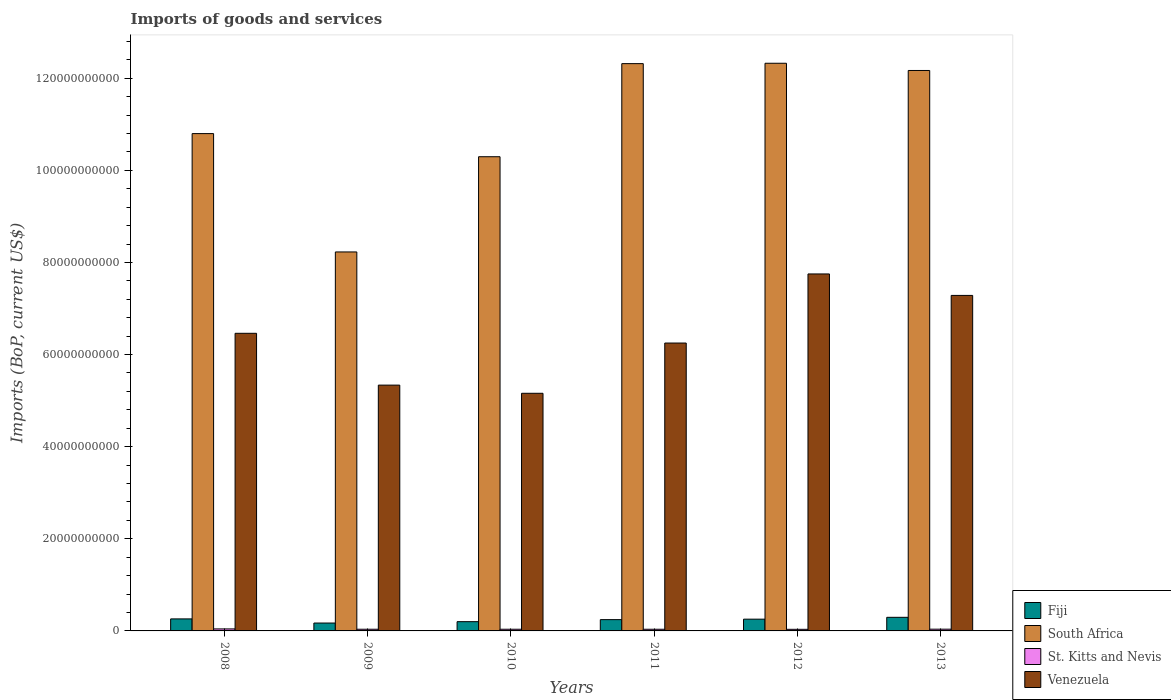How many different coloured bars are there?
Your answer should be very brief. 4. How many groups of bars are there?
Make the answer very short. 6. What is the label of the 1st group of bars from the left?
Provide a succinct answer. 2008. What is the amount spent on imports in South Africa in 2013?
Offer a terse response. 1.22e+11. Across all years, what is the maximum amount spent on imports in South Africa?
Ensure brevity in your answer.  1.23e+11. Across all years, what is the minimum amount spent on imports in Venezuela?
Your answer should be very brief. 5.16e+1. What is the total amount spent on imports in Fiji in the graph?
Provide a succinct answer. 1.43e+1. What is the difference between the amount spent on imports in Fiji in 2008 and that in 2011?
Your answer should be very brief. 1.58e+08. What is the difference between the amount spent on imports in St. Kitts and Nevis in 2011 and the amount spent on imports in Venezuela in 2010?
Keep it short and to the point. -5.12e+1. What is the average amount spent on imports in Fiji per year?
Your answer should be very brief. 2.38e+09. In the year 2010, what is the difference between the amount spent on imports in South Africa and amount spent on imports in Venezuela?
Your answer should be very brief. 5.14e+1. What is the ratio of the amount spent on imports in St. Kitts and Nevis in 2010 to that in 2011?
Keep it short and to the point. 1.01. Is the amount spent on imports in South Africa in 2008 less than that in 2010?
Your answer should be very brief. No. Is the difference between the amount spent on imports in South Africa in 2012 and 2013 greater than the difference between the amount spent on imports in Venezuela in 2012 and 2013?
Keep it short and to the point. No. What is the difference between the highest and the second highest amount spent on imports in South Africa?
Provide a succinct answer. 8.10e+07. What is the difference between the highest and the lowest amount spent on imports in South Africa?
Keep it short and to the point. 4.10e+1. In how many years, is the amount spent on imports in South Africa greater than the average amount spent on imports in South Africa taken over all years?
Ensure brevity in your answer.  3. Is it the case that in every year, the sum of the amount spent on imports in Venezuela and amount spent on imports in Fiji is greater than the sum of amount spent on imports in South Africa and amount spent on imports in St. Kitts and Nevis?
Make the answer very short. No. What does the 4th bar from the left in 2013 represents?
Offer a very short reply. Venezuela. What does the 1st bar from the right in 2008 represents?
Keep it short and to the point. Venezuela. Is it the case that in every year, the sum of the amount spent on imports in Fiji and amount spent on imports in St. Kitts and Nevis is greater than the amount spent on imports in South Africa?
Your response must be concise. No. Where does the legend appear in the graph?
Your answer should be compact. Bottom right. What is the title of the graph?
Make the answer very short. Imports of goods and services. Does "Mali" appear as one of the legend labels in the graph?
Make the answer very short. No. What is the label or title of the Y-axis?
Provide a short and direct response. Imports (BoP, current US$). What is the Imports (BoP, current US$) in Fiji in 2008?
Your answer should be compact. 2.61e+09. What is the Imports (BoP, current US$) in South Africa in 2008?
Provide a short and direct response. 1.08e+11. What is the Imports (BoP, current US$) of St. Kitts and Nevis in 2008?
Your answer should be compact. 4.37e+08. What is the Imports (BoP, current US$) of Venezuela in 2008?
Provide a succinct answer. 6.46e+1. What is the Imports (BoP, current US$) of Fiji in 2009?
Keep it short and to the point. 1.71e+09. What is the Imports (BoP, current US$) of South Africa in 2009?
Provide a succinct answer. 8.23e+1. What is the Imports (BoP, current US$) in St. Kitts and Nevis in 2009?
Your answer should be very brief. 3.66e+08. What is the Imports (BoP, current US$) in Venezuela in 2009?
Provide a succinct answer. 5.34e+1. What is the Imports (BoP, current US$) of Fiji in 2010?
Offer a terse response. 2.01e+09. What is the Imports (BoP, current US$) in South Africa in 2010?
Keep it short and to the point. 1.03e+11. What is the Imports (BoP, current US$) of St. Kitts and Nevis in 2010?
Keep it short and to the point. 3.64e+08. What is the Imports (BoP, current US$) in Venezuela in 2010?
Offer a terse response. 5.16e+1. What is the Imports (BoP, current US$) of Fiji in 2011?
Provide a succinct answer. 2.45e+09. What is the Imports (BoP, current US$) of South Africa in 2011?
Offer a very short reply. 1.23e+11. What is the Imports (BoP, current US$) in St. Kitts and Nevis in 2011?
Make the answer very short. 3.62e+08. What is the Imports (BoP, current US$) in Venezuela in 2011?
Your response must be concise. 6.25e+1. What is the Imports (BoP, current US$) in Fiji in 2012?
Provide a succinct answer. 2.55e+09. What is the Imports (BoP, current US$) in South Africa in 2012?
Keep it short and to the point. 1.23e+11. What is the Imports (BoP, current US$) of St. Kitts and Nevis in 2012?
Provide a short and direct response. 3.47e+08. What is the Imports (BoP, current US$) in Venezuela in 2012?
Offer a very short reply. 7.75e+1. What is the Imports (BoP, current US$) in Fiji in 2013?
Offer a very short reply. 2.95e+09. What is the Imports (BoP, current US$) of South Africa in 2013?
Your response must be concise. 1.22e+11. What is the Imports (BoP, current US$) of St. Kitts and Nevis in 2013?
Offer a terse response. 3.77e+08. What is the Imports (BoP, current US$) in Venezuela in 2013?
Make the answer very short. 7.28e+1. Across all years, what is the maximum Imports (BoP, current US$) in Fiji?
Your answer should be compact. 2.95e+09. Across all years, what is the maximum Imports (BoP, current US$) in South Africa?
Ensure brevity in your answer.  1.23e+11. Across all years, what is the maximum Imports (BoP, current US$) of St. Kitts and Nevis?
Provide a succinct answer. 4.37e+08. Across all years, what is the maximum Imports (BoP, current US$) of Venezuela?
Offer a very short reply. 7.75e+1. Across all years, what is the minimum Imports (BoP, current US$) in Fiji?
Offer a terse response. 1.71e+09. Across all years, what is the minimum Imports (BoP, current US$) of South Africa?
Keep it short and to the point. 8.23e+1. Across all years, what is the minimum Imports (BoP, current US$) in St. Kitts and Nevis?
Ensure brevity in your answer.  3.47e+08. Across all years, what is the minimum Imports (BoP, current US$) of Venezuela?
Your answer should be very brief. 5.16e+1. What is the total Imports (BoP, current US$) in Fiji in the graph?
Make the answer very short. 1.43e+1. What is the total Imports (BoP, current US$) of South Africa in the graph?
Your answer should be compact. 6.61e+11. What is the total Imports (BoP, current US$) in St. Kitts and Nevis in the graph?
Your response must be concise. 2.25e+09. What is the total Imports (BoP, current US$) in Venezuela in the graph?
Provide a short and direct response. 3.82e+11. What is the difference between the Imports (BoP, current US$) of Fiji in 2008 and that in 2009?
Ensure brevity in your answer.  8.98e+08. What is the difference between the Imports (BoP, current US$) in South Africa in 2008 and that in 2009?
Give a very brief answer. 2.57e+1. What is the difference between the Imports (BoP, current US$) in St. Kitts and Nevis in 2008 and that in 2009?
Give a very brief answer. 7.09e+07. What is the difference between the Imports (BoP, current US$) of Venezuela in 2008 and that in 2009?
Give a very brief answer. 1.12e+1. What is the difference between the Imports (BoP, current US$) of Fiji in 2008 and that in 2010?
Provide a succinct answer. 6.00e+08. What is the difference between the Imports (BoP, current US$) in South Africa in 2008 and that in 2010?
Make the answer very short. 5.02e+09. What is the difference between the Imports (BoP, current US$) of St. Kitts and Nevis in 2008 and that in 2010?
Keep it short and to the point. 7.30e+07. What is the difference between the Imports (BoP, current US$) of Venezuela in 2008 and that in 2010?
Offer a terse response. 1.30e+1. What is the difference between the Imports (BoP, current US$) of Fiji in 2008 and that in 2011?
Your answer should be compact. 1.58e+08. What is the difference between the Imports (BoP, current US$) of South Africa in 2008 and that in 2011?
Your answer should be very brief. -1.52e+1. What is the difference between the Imports (BoP, current US$) of St. Kitts and Nevis in 2008 and that in 2011?
Keep it short and to the point. 7.53e+07. What is the difference between the Imports (BoP, current US$) of Venezuela in 2008 and that in 2011?
Your answer should be very brief. 2.12e+09. What is the difference between the Imports (BoP, current US$) of Fiji in 2008 and that in 2012?
Your answer should be very brief. 5.92e+07. What is the difference between the Imports (BoP, current US$) of South Africa in 2008 and that in 2012?
Your answer should be compact. -1.53e+1. What is the difference between the Imports (BoP, current US$) in St. Kitts and Nevis in 2008 and that in 2012?
Ensure brevity in your answer.  8.97e+07. What is the difference between the Imports (BoP, current US$) in Venezuela in 2008 and that in 2012?
Provide a short and direct response. -1.29e+1. What is the difference between the Imports (BoP, current US$) in Fiji in 2008 and that in 2013?
Make the answer very short. -3.44e+08. What is the difference between the Imports (BoP, current US$) of South Africa in 2008 and that in 2013?
Your answer should be compact. -1.37e+1. What is the difference between the Imports (BoP, current US$) of St. Kitts and Nevis in 2008 and that in 2013?
Offer a terse response. 5.97e+07. What is the difference between the Imports (BoP, current US$) of Venezuela in 2008 and that in 2013?
Your answer should be very brief. -8.22e+09. What is the difference between the Imports (BoP, current US$) in Fiji in 2009 and that in 2010?
Your response must be concise. -2.98e+08. What is the difference between the Imports (BoP, current US$) of South Africa in 2009 and that in 2010?
Your response must be concise. -2.07e+1. What is the difference between the Imports (BoP, current US$) of St. Kitts and Nevis in 2009 and that in 2010?
Offer a very short reply. 2.10e+06. What is the difference between the Imports (BoP, current US$) of Venezuela in 2009 and that in 2010?
Provide a succinct answer. 1.77e+09. What is the difference between the Imports (BoP, current US$) in Fiji in 2009 and that in 2011?
Your response must be concise. -7.40e+08. What is the difference between the Imports (BoP, current US$) of South Africa in 2009 and that in 2011?
Offer a very short reply. -4.09e+1. What is the difference between the Imports (BoP, current US$) in St. Kitts and Nevis in 2009 and that in 2011?
Offer a terse response. 4.44e+06. What is the difference between the Imports (BoP, current US$) in Venezuela in 2009 and that in 2011?
Your answer should be compact. -9.14e+09. What is the difference between the Imports (BoP, current US$) of Fiji in 2009 and that in 2012?
Provide a short and direct response. -8.39e+08. What is the difference between the Imports (BoP, current US$) in South Africa in 2009 and that in 2012?
Your answer should be compact. -4.10e+1. What is the difference between the Imports (BoP, current US$) of St. Kitts and Nevis in 2009 and that in 2012?
Your answer should be compact. 1.88e+07. What is the difference between the Imports (BoP, current US$) in Venezuela in 2009 and that in 2012?
Your answer should be compact. -2.41e+1. What is the difference between the Imports (BoP, current US$) in Fiji in 2009 and that in 2013?
Keep it short and to the point. -1.24e+09. What is the difference between the Imports (BoP, current US$) of South Africa in 2009 and that in 2013?
Give a very brief answer. -3.94e+1. What is the difference between the Imports (BoP, current US$) in St. Kitts and Nevis in 2009 and that in 2013?
Offer a very short reply. -1.12e+07. What is the difference between the Imports (BoP, current US$) in Venezuela in 2009 and that in 2013?
Provide a short and direct response. -1.95e+1. What is the difference between the Imports (BoP, current US$) of Fiji in 2010 and that in 2011?
Offer a very short reply. -4.42e+08. What is the difference between the Imports (BoP, current US$) of South Africa in 2010 and that in 2011?
Your answer should be compact. -2.02e+1. What is the difference between the Imports (BoP, current US$) in St. Kitts and Nevis in 2010 and that in 2011?
Provide a succinct answer. 2.35e+06. What is the difference between the Imports (BoP, current US$) of Venezuela in 2010 and that in 2011?
Offer a terse response. -1.09e+1. What is the difference between the Imports (BoP, current US$) of Fiji in 2010 and that in 2012?
Make the answer very short. -5.41e+08. What is the difference between the Imports (BoP, current US$) of South Africa in 2010 and that in 2012?
Keep it short and to the point. -2.03e+1. What is the difference between the Imports (BoP, current US$) in St. Kitts and Nevis in 2010 and that in 2012?
Offer a very short reply. 1.67e+07. What is the difference between the Imports (BoP, current US$) of Venezuela in 2010 and that in 2012?
Ensure brevity in your answer.  -2.59e+1. What is the difference between the Imports (BoP, current US$) in Fiji in 2010 and that in 2013?
Your answer should be compact. -9.44e+08. What is the difference between the Imports (BoP, current US$) of South Africa in 2010 and that in 2013?
Keep it short and to the point. -1.87e+1. What is the difference between the Imports (BoP, current US$) in St. Kitts and Nevis in 2010 and that in 2013?
Provide a short and direct response. -1.33e+07. What is the difference between the Imports (BoP, current US$) of Venezuela in 2010 and that in 2013?
Offer a terse response. -2.12e+1. What is the difference between the Imports (BoP, current US$) in Fiji in 2011 and that in 2012?
Your response must be concise. -9.92e+07. What is the difference between the Imports (BoP, current US$) in South Africa in 2011 and that in 2012?
Your answer should be compact. -8.10e+07. What is the difference between the Imports (BoP, current US$) in St. Kitts and Nevis in 2011 and that in 2012?
Offer a terse response. 1.44e+07. What is the difference between the Imports (BoP, current US$) of Venezuela in 2011 and that in 2012?
Provide a short and direct response. -1.50e+1. What is the difference between the Imports (BoP, current US$) in Fiji in 2011 and that in 2013?
Offer a very short reply. -5.02e+08. What is the difference between the Imports (BoP, current US$) of South Africa in 2011 and that in 2013?
Offer a terse response. 1.49e+09. What is the difference between the Imports (BoP, current US$) of St. Kitts and Nevis in 2011 and that in 2013?
Offer a very short reply. -1.56e+07. What is the difference between the Imports (BoP, current US$) in Venezuela in 2011 and that in 2013?
Offer a terse response. -1.03e+1. What is the difference between the Imports (BoP, current US$) of Fiji in 2012 and that in 2013?
Your answer should be compact. -4.03e+08. What is the difference between the Imports (BoP, current US$) of South Africa in 2012 and that in 2013?
Provide a succinct answer. 1.57e+09. What is the difference between the Imports (BoP, current US$) of St. Kitts and Nevis in 2012 and that in 2013?
Provide a succinct answer. -3.00e+07. What is the difference between the Imports (BoP, current US$) in Venezuela in 2012 and that in 2013?
Make the answer very short. 4.66e+09. What is the difference between the Imports (BoP, current US$) in Fiji in 2008 and the Imports (BoP, current US$) in South Africa in 2009?
Give a very brief answer. -7.97e+1. What is the difference between the Imports (BoP, current US$) of Fiji in 2008 and the Imports (BoP, current US$) of St. Kitts and Nevis in 2009?
Make the answer very short. 2.24e+09. What is the difference between the Imports (BoP, current US$) of Fiji in 2008 and the Imports (BoP, current US$) of Venezuela in 2009?
Ensure brevity in your answer.  -5.08e+1. What is the difference between the Imports (BoP, current US$) of South Africa in 2008 and the Imports (BoP, current US$) of St. Kitts and Nevis in 2009?
Offer a very short reply. 1.08e+11. What is the difference between the Imports (BoP, current US$) in South Africa in 2008 and the Imports (BoP, current US$) in Venezuela in 2009?
Provide a short and direct response. 5.46e+1. What is the difference between the Imports (BoP, current US$) of St. Kitts and Nevis in 2008 and the Imports (BoP, current US$) of Venezuela in 2009?
Keep it short and to the point. -5.29e+1. What is the difference between the Imports (BoP, current US$) of Fiji in 2008 and the Imports (BoP, current US$) of South Africa in 2010?
Keep it short and to the point. -1.00e+11. What is the difference between the Imports (BoP, current US$) of Fiji in 2008 and the Imports (BoP, current US$) of St. Kitts and Nevis in 2010?
Ensure brevity in your answer.  2.25e+09. What is the difference between the Imports (BoP, current US$) of Fiji in 2008 and the Imports (BoP, current US$) of Venezuela in 2010?
Keep it short and to the point. -4.90e+1. What is the difference between the Imports (BoP, current US$) in South Africa in 2008 and the Imports (BoP, current US$) in St. Kitts and Nevis in 2010?
Make the answer very short. 1.08e+11. What is the difference between the Imports (BoP, current US$) of South Africa in 2008 and the Imports (BoP, current US$) of Venezuela in 2010?
Ensure brevity in your answer.  5.64e+1. What is the difference between the Imports (BoP, current US$) of St. Kitts and Nevis in 2008 and the Imports (BoP, current US$) of Venezuela in 2010?
Provide a short and direct response. -5.12e+1. What is the difference between the Imports (BoP, current US$) in Fiji in 2008 and the Imports (BoP, current US$) in South Africa in 2011?
Your response must be concise. -1.21e+11. What is the difference between the Imports (BoP, current US$) in Fiji in 2008 and the Imports (BoP, current US$) in St. Kitts and Nevis in 2011?
Offer a terse response. 2.25e+09. What is the difference between the Imports (BoP, current US$) in Fiji in 2008 and the Imports (BoP, current US$) in Venezuela in 2011?
Provide a short and direct response. -5.99e+1. What is the difference between the Imports (BoP, current US$) of South Africa in 2008 and the Imports (BoP, current US$) of St. Kitts and Nevis in 2011?
Offer a very short reply. 1.08e+11. What is the difference between the Imports (BoP, current US$) of South Africa in 2008 and the Imports (BoP, current US$) of Venezuela in 2011?
Your answer should be compact. 4.55e+1. What is the difference between the Imports (BoP, current US$) of St. Kitts and Nevis in 2008 and the Imports (BoP, current US$) of Venezuela in 2011?
Give a very brief answer. -6.21e+1. What is the difference between the Imports (BoP, current US$) in Fiji in 2008 and the Imports (BoP, current US$) in South Africa in 2012?
Make the answer very short. -1.21e+11. What is the difference between the Imports (BoP, current US$) of Fiji in 2008 and the Imports (BoP, current US$) of St. Kitts and Nevis in 2012?
Your answer should be very brief. 2.26e+09. What is the difference between the Imports (BoP, current US$) of Fiji in 2008 and the Imports (BoP, current US$) of Venezuela in 2012?
Make the answer very short. -7.49e+1. What is the difference between the Imports (BoP, current US$) of South Africa in 2008 and the Imports (BoP, current US$) of St. Kitts and Nevis in 2012?
Provide a short and direct response. 1.08e+11. What is the difference between the Imports (BoP, current US$) of South Africa in 2008 and the Imports (BoP, current US$) of Venezuela in 2012?
Ensure brevity in your answer.  3.05e+1. What is the difference between the Imports (BoP, current US$) in St. Kitts and Nevis in 2008 and the Imports (BoP, current US$) in Venezuela in 2012?
Provide a succinct answer. -7.71e+1. What is the difference between the Imports (BoP, current US$) of Fiji in 2008 and the Imports (BoP, current US$) of South Africa in 2013?
Keep it short and to the point. -1.19e+11. What is the difference between the Imports (BoP, current US$) of Fiji in 2008 and the Imports (BoP, current US$) of St. Kitts and Nevis in 2013?
Your answer should be very brief. 2.23e+09. What is the difference between the Imports (BoP, current US$) in Fiji in 2008 and the Imports (BoP, current US$) in Venezuela in 2013?
Keep it short and to the point. -7.02e+1. What is the difference between the Imports (BoP, current US$) in South Africa in 2008 and the Imports (BoP, current US$) in St. Kitts and Nevis in 2013?
Your answer should be very brief. 1.08e+11. What is the difference between the Imports (BoP, current US$) in South Africa in 2008 and the Imports (BoP, current US$) in Venezuela in 2013?
Your answer should be compact. 3.51e+1. What is the difference between the Imports (BoP, current US$) in St. Kitts and Nevis in 2008 and the Imports (BoP, current US$) in Venezuela in 2013?
Offer a terse response. -7.24e+1. What is the difference between the Imports (BoP, current US$) in Fiji in 2009 and the Imports (BoP, current US$) in South Africa in 2010?
Provide a succinct answer. -1.01e+11. What is the difference between the Imports (BoP, current US$) in Fiji in 2009 and the Imports (BoP, current US$) in St. Kitts and Nevis in 2010?
Provide a succinct answer. 1.35e+09. What is the difference between the Imports (BoP, current US$) in Fiji in 2009 and the Imports (BoP, current US$) in Venezuela in 2010?
Offer a very short reply. -4.99e+1. What is the difference between the Imports (BoP, current US$) of South Africa in 2009 and the Imports (BoP, current US$) of St. Kitts and Nevis in 2010?
Provide a short and direct response. 8.19e+1. What is the difference between the Imports (BoP, current US$) in South Africa in 2009 and the Imports (BoP, current US$) in Venezuela in 2010?
Give a very brief answer. 3.07e+1. What is the difference between the Imports (BoP, current US$) of St. Kitts and Nevis in 2009 and the Imports (BoP, current US$) of Venezuela in 2010?
Give a very brief answer. -5.12e+1. What is the difference between the Imports (BoP, current US$) of Fiji in 2009 and the Imports (BoP, current US$) of South Africa in 2011?
Ensure brevity in your answer.  -1.21e+11. What is the difference between the Imports (BoP, current US$) of Fiji in 2009 and the Imports (BoP, current US$) of St. Kitts and Nevis in 2011?
Make the answer very short. 1.35e+09. What is the difference between the Imports (BoP, current US$) in Fiji in 2009 and the Imports (BoP, current US$) in Venezuela in 2011?
Keep it short and to the point. -6.08e+1. What is the difference between the Imports (BoP, current US$) in South Africa in 2009 and the Imports (BoP, current US$) in St. Kitts and Nevis in 2011?
Ensure brevity in your answer.  8.19e+1. What is the difference between the Imports (BoP, current US$) in South Africa in 2009 and the Imports (BoP, current US$) in Venezuela in 2011?
Your answer should be compact. 1.98e+1. What is the difference between the Imports (BoP, current US$) in St. Kitts and Nevis in 2009 and the Imports (BoP, current US$) in Venezuela in 2011?
Offer a terse response. -6.21e+1. What is the difference between the Imports (BoP, current US$) of Fiji in 2009 and the Imports (BoP, current US$) of South Africa in 2012?
Ensure brevity in your answer.  -1.22e+11. What is the difference between the Imports (BoP, current US$) in Fiji in 2009 and the Imports (BoP, current US$) in St. Kitts and Nevis in 2012?
Your response must be concise. 1.36e+09. What is the difference between the Imports (BoP, current US$) in Fiji in 2009 and the Imports (BoP, current US$) in Venezuela in 2012?
Your response must be concise. -7.58e+1. What is the difference between the Imports (BoP, current US$) in South Africa in 2009 and the Imports (BoP, current US$) in St. Kitts and Nevis in 2012?
Give a very brief answer. 8.19e+1. What is the difference between the Imports (BoP, current US$) of South Africa in 2009 and the Imports (BoP, current US$) of Venezuela in 2012?
Give a very brief answer. 4.78e+09. What is the difference between the Imports (BoP, current US$) of St. Kitts and Nevis in 2009 and the Imports (BoP, current US$) of Venezuela in 2012?
Make the answer very short. -7.71e+1. What is the difference between the Imports (BoP, current US$) in Fiji in 2009 and the Imports (BoP, current US$) in South Africa in 2013?
Offer a terse response. -1.20e+11. What is the difference between the Imports (BoP, current US$) of Fiji in 2009 and the Imports (BoP, current US$) of St. Kitts and Nevis in 2013?
Offer a terse response. 1.33e+09. What is the difference between the Imports (BoP, current US$) of Fiji in 2009 and the Imports (BoP, current US$) of Venezuela in 2013?
Your response must be concise. -7.11e+1. What is the difference between the Imports (BoP, current US$) in South Africa in 2009 and the Imports (BoP, current US$) in St. Kitts and Nevis in 2013?
Provide a short and direct response. 8.19e+1. What is the difference between the Imports (BoP, current US$) in South Africa in 2009 and the Imports (BoP, current US$) in Venezuela in 2013?
Ensure brevity in your answer.  9.44e+09. What is the difference between the Imports (BoP, current US$) in St. Kitts and Nevis in 2009 and the Imports (BoP, current US$) in Venezuela in 2013?
Your answer should be very brief. -7.25e+1. What is the difference between the Imports (BoP, current US$) in Fiji in 2010 and the Imports (BoP, current US$) in South Africa in 2011?
Provide a succinct answer. -1.21e+11. What is the difference between the Imports (BoP, current US$) of Fiji in 2010 and the Imports (BoP, current US$) of St. Kitts and Nevis in 2011?
Provide a succinct answer. 1.65e+09. What is the difference between the Imports (BoP, current US$) in Fiji in 2010 and the Imports (BoP, current US$) in Venezuela in 2011?
Ensure brevity in your answer.  -6.05e+1. What is the difference between the Imports (BoP, current US$) in South Africa in 2010 and the Imports (BoP, current US$) in St. Kitts and Nevis in 2011?
Ensure brevity in your answer.  1.03e+11. What is the difference between the Imports (BoP, current US$) of South Africa in 2010 and the Imports (BoP, current US$) of Venezuela in 2011?
Your answer should be very brief. 4.05e+1. What is the difference between the Imports (BoP, current US$) of St. Kitts and Nevis in 2010 and the Imports (BoP, current US$) of Venezuela in 2011?
Offer a terse response. -6.21e+1. What is the difference between the Imports (BoP, current US$) in Fiji in 2010 and the Imports (BoP, current US$) in South Africa in 2012?
Your answer should be compact. -1.21e+11. What is the difference between the Imports (BoP, current US$) of Fiji in 2010 and the Imports (BoP, current US$) of St. Kitts and Nevis in 2012?
Offer a terse response. 1.66e+09. What is the difference between the Imports (BoP, current US$) of Fiji in 2010 and the Imports (BoP, current US$) of Venezuela in 2012?
Ensure brevity in your answer.  -7.55e+1. What is the difference between the Imports (BoP, current US$) of South Africa in 2010 and the Imports (BoP, current US$) of St. Kitts and Nevis in 2012?
Offer a terse response. 1.03e+11. What is the difference between the Imports (BoP, current US$) in South Africa in 2010 and the Imports (BoP, current US$) in Venezuela in 2012?
Provide a short and direct response. 2.55e+1. What is the difference between the Imports (BoP, current US$) of St. Kitts and Nevis in 2010 and the Imports (BoP, current US$) of Venezuela in 2012?
Your answer should be very brief. -7.71e+1. What is the difference between the Imports (BoP, current US$) in Fiji in 2010 and the Imports (BoP, current US$) in South Africa in 2013?
Offer a very short reply. -1.20e+11. What is the difference between the Imports (BoP, current US$) in Fiji in 2010 and the Imports (BoP, current US$) in St. Kitts and Nevis in 2013?
Offer a very short reply. 1.63e+09. What is the difference between the Imports (BoP, current US$) of Fiji in 2010 and the Imports (BoP, current US$) of Venezuela in 2013?
Ensure brevity in your answer.  -7.08e+1. What is the difference between the Imports (BoP, current US$) of South Africa in 2010 and the Imports (BoP, current US$) of St. Kitts and Nevis in 2013?
Your response must be concise. 1.03e+11. What is the difference between the Imports (BoP, current US$) in South Africa in 2010 and the Imports (BoP, current US$) in Venezuela in 2013?
Your answer should be compact. 3.01e+1. What is the difference between the Imports (BoP, current US$) of St. Kitts and Nevis in 2010 and the Imports (BoP, current US$) of Venezuela in 2013?
Give a very brief answer. -7.25e+1. What is the difference between the Imports (BoP, current US$) in Fiji in 2011 and the Imports (BoP, current US$) in South Africa in 2012?
Your answer should be very brief. -1.21e+11. What is the difference between the Imports (BoP, current US$) in Fiji in 2011 and the Imports (BoP, current US$) in St. Kitts and Nevis in 2012?
Provide a short and direct response. 2.10e+09. What is the difference between the Imports (BoP, current US$) in Fiji in 2011 and the Imports (BoP, current US$) in Venezuela in 2012?
Provide a succinct answer. -7.51e+1. What is the difference between the Imports (BoP, current US$) of South Africa in 2011 and the Imports (BoP, current US$) of St. Kitts and Nevis in 2012?
Provide a short and direct response. 1.23e+11. What is the difference between the Imports (BoP, current US$) in South Africa in 2011 and the Imports (BoP, current US$) in Venezuela in 2012?
Offer a very short reply. 4.57e+1. What is the difference between the Imports (BoP, current US$) in St. Kitts and Nevis in 2011 and the Imports (BoP, current US$) in Venezuela in 2012?
Make the answer very short. -7.71e+1. What is the difference between the Imports (BoP, current US$) of Fiji in 2011 and the Imports (BoP, current US$) of South Africa in 2013?
Make the answer very short. -1.19e+11. What is the difference between the Imports (BoP, current US$) in Fiji in 2011 and the Imports (BoP, current US$) in St. Kitts and Nevis in 2013?
Make the answer very short. 2.07e+09. What is the difference between the Imports (BoP, current US$) in Fiji in 2011 and the Imports (BoP, current US$) in Venezuela in 2013?
Give a very brief answer. -7.04e+1. What is the difference between the Imports (BoP, current US$) of South Africa in 2011 and the Imports (BoP, current US$) of St. Kitts and Nevis in 2013?
Provide a succinct answer. 1.23e+11. What is the difference between the Imports (BoP, current US$) of South Africa in 2011 and the Imports (BoP, current US$) of Venezuela in 2013?
Your answer should be very brief. 5.03e+1. What is the difference between the Imports (BoP, current US$) in St. Kitts and Nevis in 2011 and the Imports (BoP, current US$) in Venezuela in 2013?
Your answer should be compact. -7.25e+1. What is the difference between the Imports (BoP, current US$) in Fiji in 2012 and the Imports (BoP, current US$) in South Africa in 2013?
Your answer should be very brief. -1.19e+11. What is the difference between the Imports (BoP, current US$) of Fiji in 2012 and the Imports (BoP, current US$) of St. Kitts and Nevis in 2013?
Keep it short and to the point. 2.17e+09. What is the difference between the Imports (BoP, current US$) of Fiji in 2012 and the Imports (BoP, current US$) of Venezuela in 2013?
Your response must be concise. -7.03e+1. What is the difference between the Imports (BoP, current US$) of South Africa in 2012 and the Imports (BoP, current US$) of St. Kitts and Nevis in 2013?
Keep it short and to the point. 1.23e+11. What is the difference between the Imports (BoP, current US$) in South Africa in 2012 and the Imports (BoP, current US$) in Venezuela in 2013?
Keep it short and to the point. 5.04e+1. What is the difference between the Imports (BoP, current US$) in St. Kitts and Nevis in 2012 and the Imports (BoP, current US$) in Venezuela in 2013?
Provide a succinct answer. -7.25e+1. What is the average Imports (BoP, current US$) of Fiji per year?
Your answer should be very brief. 2.38e+09. What is the average Imports (BoP, current US$) of South Africa per year?
Make the answer very short. 1.10e+11. What is the average Imports (BoP, current US$) of St. Kitts and Nevis per year?
Keep it short and to the point. 3.76e+08. What is the average Imports (BoP, current US$) in Venezuela per year?
Make the answer very short. 6.37e+1. In the year 2008, what is the difference between the Imports (BoP, current US$) of Fiji and Imports (BoP, current US$) of South Africa?
Offer a very short reply. -1.05e+11. In the year 2008, what is the difference between the Imports (BoP, current US$) of Fiji and Imports (BoP, current US$) of St. Kitts and Nevis?
Give a very brief answer. 2.17e+09. In the year 2008, what is the difference between the Imports (BoP, current US$) of Fiji and Imports (BoP, current US$) of Venezuela?
Your response must be concise. -6.20e+1. In the year 2008, what is the difference between the Imports (BoP, current US$) in South Africa and Imports (BoP, current US$) in St. Kitts and Nevis?
Provide a short and direct response. 1.08e+11. In the year 2008, what is the difference between the Imports (BoP, current US$) of South Africa and Imports (BoP, current US$) of Venezuela?
Provide a succinct answer. 4.34e+1. In the year 2008, what is the difference between the Imports (BoP, current US$) of St. Kitts and Nevis and Imports (BoP, current US$) of Venezuela?
Keep it short and to the point. -6.42e+1. In the year 2009, what is the difference between the Imports (BoP, current US$) of Fiji and Imports (BoP, current US$) of South Africa?
Your response must be concise. -8.06e+1. In the year 2009, what is the difference between the Imports (BoP, current US$) in Fiji and Imports (BoP, current US$) in St. Kitts and Nevis?
Provide a short and direct response. 1.35e+09. In the year 2009, what is the difference between the Imports (BoP, current US$) of Fiji and Imports (BoP, current US$) of Venezuela?
Give a very brief answer. -5.17e+1. In the year 2009, what is the difference between the Imports (BoP, current US$) in South Africa and Imports (BoP, current US$) in St. Kitts and Nevis?
Provide a succinct answer. 8.19e+1. In the year 2009, what is the difference between the Imports (BoP, current US$) of South Africa and Imports (BoP, current US$) of Venezuela?
Provide a short and direct response. 2.89e+1. In the year 2009, what is the difference between the Imports (BoP, current US$) in St. Kitts and Nevis and Imports (BoP, current US$) in Venezuela?
Your answer should be very brief. -5.30e+1. In the year 2010, what is the difference between the Imports (BoP, current US$) of Fiji and Imports (BoP, current US$) of South Africa?
Offer a very short reply. -1.01e+11. In the year 2010, what is the difference between the Imports (BoP, current US$) of Fiji and Imports (BoP, current US$) of St. Kitts and Nevis?
Your answer should be very brief. 1.65e+09. In the year 2010, what is the difference between the Imports (BoP, current US$) of Fiji and Imports (BoP, current US$) of Venezuela?
Make the answer very short. -4.96e+1. In the year 2010, what is the difference between the Imports (BoP, current US$) of South Africa and Imports (BoP, current US$) of St. Kitts and Nevis?
Ensure brevity in your answer.  1.03e+11. In the year 2010, what is the difference between the Imports (BoP, current US$) of South Africa and Imports (BoP, current US$) of Venezuela?
Your response must be concise. 5.14e+1. In the year 2010, what is the difference between the Imports (BoP, current US$) of St. Kitts and Nevis and Imports (BoP, current US$) of Venezuela?
Give a very brief answer. -5.12e+1. In the year 2011, what is the difference between the Imports (BoP, current US$) in Fiji and Imports (BoP, current US$) in South Africa?
Make the answer very short. -1.21e+11. In the year 2011, what is the difference between the Imports (BoP, current US$) in Fiji and Imports (BoP, current US$) in St. Kitts and Nevis?
Offer a terse response. 2.09e+09. In the year 2011, what is the difference between the Imports (BoP, current US$) in Fiji and Imports (BoP, current US$) in Venezuela?
Ensure brevity in your answer.  -6.01e+1. In the year 2011, what is the difference between the Imports (BoP, current US$) of South Africa and Imports (BoP, current US$) of St. Kitts and Nevis?
Give a very brief answer. 1.23e+11. In the year 2011, what is the difference between the Imports (BoP, current US$) in South Africa and Imports (BoP, current US$) in Venezuela?
Offer a terse response. 6.07e+1. In the year 2011, what is the difference between the Imports (BoP, current US$) of St. Kitts and Nevis and Imports (BoP, current US$) of Venezuela?
Ensure brevity in your answer.  -6.21e+1. In the year 2012, what is the difference between the Imports (BoP, current US$) in Fiji and Imports (BoP, current US$) in South Africa?
Offer a terse response. -1.21e+11. In the year 2012, what is the difference between the Imports (BoP, current US$) of Fiji and Imports (BoP, current US$) of St. Kitts and Nevis?
Ensure brevity in your answer.  2.20e+09. In the year 2012, what is the difference between the Imports (BoP, current US$) of Fiji and Imports (BoP, current US$) of Venezuela?
Give a very brief answer. -7.50e+1. In the year 2012, what is the difference between the Imports (BoP, current US$) of South Africa and Imports (BoP, current US$) of St. Kitts and Nevis?
Offer a very short reply. 1.23e+11. In the year 2012, what is the difference between the Imports (BoP, current US$) of South Africa and Imports (BoP, current US$) of Venezuela?
Provide a succinct answer. 4.57e+1. In the year 2012, what is the difference between the Imports (BoP, current US$) in St. Kitts and Nevis and Imports (BoP, current US$) in Venezuela?
Provide a short and direct response. -7.72e+1. In the year 2013, what is the difference between the Imports (BoP, current US$) in Fiji and Imports (BoP, current US$) in South Africa?
Provide a short and direct response. -1.19e+11. In the year 2013, what is the difference between the Imports (BoP, current US$) in Fiji and Imports (BoP, current US$) in St. Kitts and Nevis?
Provide a short and direct response. 2.58e+09. In the year 2013, what is the difference between the Imports (BoP, current US$) in Fiji and Imports (BoP, current US$) in Venezuela?
Provide a succinct answer. -6.99e+1. In the year 2013, what is the difference between the Imports (BoP, current US$) of South Africa and Imports (BoP, current US$) of St. Kitts and Nevis?
Your response must be concise. 1.21e+11. In the year 2013, what is the difference between the Imports (BoP, current US$) in South Africa and Imports (BoP, current US$) in Venezuela?
Your answer should be compact. 4.88e+1. In the year 2013, what is the difference between the Imports (BoP, current US$) of St. Kitts and Nevis and Imports (BoP, current US$) of Venezuela?
Your answer should be very brief. -7.25e+1. What is the ratio of the Imports (BoP, current US$) in Fiji in 2008 to that in 2009?
Provide a short and direct response. 1.52. What is the ratio of the Imports (BoP, current US$) of South Africa in 2008 to that in 2009?
Offer a terse response. 1.31. What is the ratio of the Imports (BoP, current US$) of St. Kitts and Nevis in 2008 to that in 2009?
Keep it short and to the point. 1.19. What is the ratio of the Imports (BoP, current US$) of Venezuela in 2008 to that in 2009?
Your answer should be compact. 1.21. What is the ratio of the Imports (BoP, current US$) in Fiji in 2008 to that in 2010?
Your answer should be very brief. 1.3. What is the ratio of the Imports (BoP, current US$) in South Africa in 2008 to that in 2010?
Keep it short and to the point. 1.05. What is the ratio of the Imports (BoP, current US$) in St. Kitts and Nevis in 2008 to that in 2010?
Offer a terse response. 1.2. What is the ratio of the Imports (BoP, current US$) in Venezuela in 2008 to that in 2010?
Keep it short and to the point. 1.25. What is the ratio of the Imports (BoP, current US$) in Fiji in 2008 to that in 2011?
Your answer should be compact. 1.06. What is the ratio of the Imports (BoP, current US$) in South Africa in 2008 to that in 2011?
Give a very brief answer. 0.88. What is the ratio of the Imports (BoP, current US$) in St. Kitts and Nevis in 2008 to that in 2011?
Provide a succinct answer. 1.21. What is the ratio of the Imports (BoP, current US$) of Venezuela in 2008 to that in 2011?
Your response must be concise. 1.03. What is the ratio of the Imports (BoP, current US$) of Fiji in 2008 to that in 2012?
Offer a terse response. 1.02. What is the ratio of the Imports (BoP, current US$) in South Africa in 2008 to that in 2012?
Offer a terse response. 0.88. What is the ratio of the Imports (BoP, current US$) of St. Kitts and Nevis in 2008 to that in 2012?
Keep it short and to the point. 1.26. What is the ratio of the Imports (BoP, current US$) in Venezuela in 2008 to that in 2012?
Your answer should be compact. 0.83. What is the ratio of the Imports (BoP, current US$) in Fiji in 2008 to that in 2013?
Your answer should be compact. 0.88. What is the ratio of the Imports (BoP, current US$) in South Africa in 2008 to that in 2013?
Provide a succinct answer. 0.89. What is the ratio of the Imports (BoP, current US$) in St. Kitts and Nevis in 2008 to that in 2013?
Ensure brevity in your answer.  1.16. What is the ratio of the Imports (BoP, current US$) of Venezuela in 2008 to that in 2013?
Offer a very short reply. 0.89. What is the ratio of the Imports (BoP, current US$) of Fiji in 2009 to that in 2010?
Make the answer very short. 0.85. What is the ratio of the Imports (BoP, current US$) in South Africa in 2009 to that in 2010?
Offer a very short reply. 0.8. What is the ratio of the Imports (BoP, current US$) in St. Kitts and Nevis in 2009 to that in 2010?
Make the answer very short. 1.01. What is the ratio of the Imports (BoP, current US$) in Venezuela in 2009 to that in 2010?
Offer a terse response. 1.03. What is the ratio of the Imports (BoP, current US$) of Fiji in 2009 to that in 2011?
Offer a terse response. 0.7. What is the ratio of the Imports (BoP, current US$) of South Africa in 2009 to that in 2011?
Offer a terse response. 0.67. What is the ratio of the Imports (BoP, current US$) of St. Kitts and Nevis in 2009 to that in 2011?
Provide a succinct answer. 1.01. What is the ratio of the Imports (BoP, current US$) of Venezuela in 2009 to that in 2011?
Ensure brevity in your answer.  0.85. What is the ratio of the Imports (BoP, current US$) of Fiji in 2009 to that in 2012?
Provide a short and direct response. 0.67. What is the ratio of the Imports (BoP, current US$) of South Africa in 2009 to that in 2012?
Offer a very short reply. 0.67. What is the ratio of the Imports (BoP, current US$) of St. Kitts and Nevis in 2009 to that in 2012?
Offer a terse response. 1.05. What is the ratio of the Imports (BoP, current US$) of Venezuela in 2009 to that in 2012?
Provide a short and direct response. 0.69. What is the ratio of the Imports (BoP, current US$) of Fiji in 2009 to that in 2013?
Give a very brief answer. 0.58. What is the ratio of the Imports (BoP, current US$) in South Africa in 2009 to that in 2013?
Your response must be concise. 0.68. What is the ratio of the Imports (BoP, current US$) of St. Kitts and Nevis in 2009 to that in 2013?
Your answer should be very brief. 0.97. What is the ratio of the Imports (BoP, current US$) of Venezuela in 2009 to that in 2013?
Your answer should be compact. 0.73. What is the ratio of the Imports (BoP, current US$) in Fiji in 2010 to that in 2011?
Your response must be concise. 0.82. What is the ratio of the Imports (BoP, current US$) of South Africa in 2010 to that in 2011?
Provide a short and direct response. 0.84. What is the ratio of the Imports (BoP, current US$) of St. Kitts and Nevis in 2010 to that in 2011?
Offer a very short reply. 1.01. What is the ratio of the Imports (BoP, current US$) in Venezuela in 2010 to that in 2011?
Offer a terse response. 0.83. What is the ratio of the Imports (BoP, current US$) in Fiji in 2010 to that in 2012?
Offer a terse response. 0.79. What is the ratio of the Imports (BoP, current US$) of South Africa in 2010 to that in 2012?
Your answer should be compact. 0.84. What is the ratio of the Imports (BoP, current US$) in St. Kitts and Nevis in 2010 to that in 2012?
Keep it short and to the point. 1.05. What is the ratio of the Imports (BoP, current US$) in Venezuela in 2010 to that in 2012?
Provide a succinct answer. 0.67. What is the ratio of the Imports (BoP, current US$) in Fiji in 2010 to that in 2013?
Your response must be concise. 0.68. What is the ratio of the Imports (BoP, current US$) of South Africa in 2010 to that in 2013?
Your answer should be compact. 0.85. What is the ratio of the Imports (BoP, current US$) of St. Kitts and Nevis in 2010 to that in 2013?
Give a very brief answer. 0.96. What is the ratio of the Imports (BoP, current US$) of Venezuela in 2010 to that in 2013?
Provide a short and direct response. 0.71. What is the ratio of the Imports (BoP, current US$) of Fiji in 2011 to that in 2012?
Provide a succinct answer. 0.96. What is the ratio of the Imports (BoP, current US$) in St. Kitts and Nevis in 2011 to that in 2012?
Your response must be concise. 1.04. What is the ratio of the Imports (BoP, current US$) of Venezuela in 2011 to that in 2012?
Your response must be concise. 0.81. What is the ratio of the Imports (BoP, current US$) in Fiji in 2011 to that in 2013?
Give a very brief answer. 0.83. What is the ratio of the Imports (BoP, current US$) of South Africa in 2011 to that in 2013?
Your answer should be compact. 1.01. What is the ratio of the Imports (BoP, current US$) in St. Kitts and Nevis in 2011 to that in 2013?
Offer a very short reply. 0.96. What is the ratio of the Imports (BoP, current US$) in Venezuela in 2011 to that in 2013?
Your response must be concise. 0.86. What is the ratio of the Imports (BoP, current US$) of Fiji in 2012 to that in 2013?
Provide a succinct answer. 0.86. What is the ratio of the Imports (BoP, current US$) in South Africa in 2012 to that in 2013?
Your answer should be compact. 1.01. What is the ratio of the Imports (BoP, current US$) in St. Kitts and Nevis in 2012 to that in 2013?
Ensure brevity in your answer.  0.92. What is the ratio of the Imports (BoP, current US$) in Venezuela in 2012 to that in 2013?
Give a very brief answer. 1.06. What is the difference between the highest and the second highest Imports (BoP, current US$) in Fiji?
Give a very brief answer. 3.44e+08. What is the difference between the highest and the second highest Imports (BoP, current US$) of South Africa?
Keep it short and to the point. 8.10e+07. What is the difference between the highest and the second highest Imports (BoP, current US$) in St. Kitts and Nevis?
Your answer should be very brief. 5.97e+07. What is the difference between the highest and the second highest Imports (BoP, current US$) of Venezuela?
Make the answer very short. 4.66e+09. What is the difference between the highest and the lowest Imports (BoP, current US$) in Fiji?
Your answer should be compact. 1.24e+09. What is the difference between the highest and the lowest Imports (BoP, current US$) in South Africa?
Ensure brevity in your answer.  4.10e+1. What is the difference between the highest and the lowest Imports (BoP, current US$) in St. Kitts and Nevis?
Provide a short and direct response. 8.97e+07. What is the difference between the highest and the lowest Imports (BoP, current US$) in Venezuela?
Keep it short and to the point. 2.59e+1. 